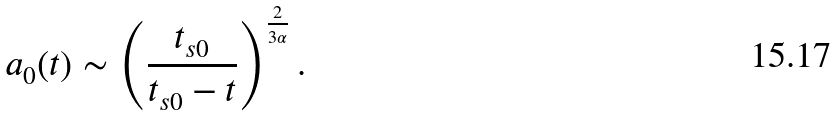Convert formula to latex. <formula><loc_0><loc_0><loc_500><loc_500>a _ { 0 } ( t ) \sim \left ( \frac { t _ { s 0 } } { t _ { s 0 } - t } \right ) ^ { \frac { 2 } { 3 \alpha } } .</formula> 